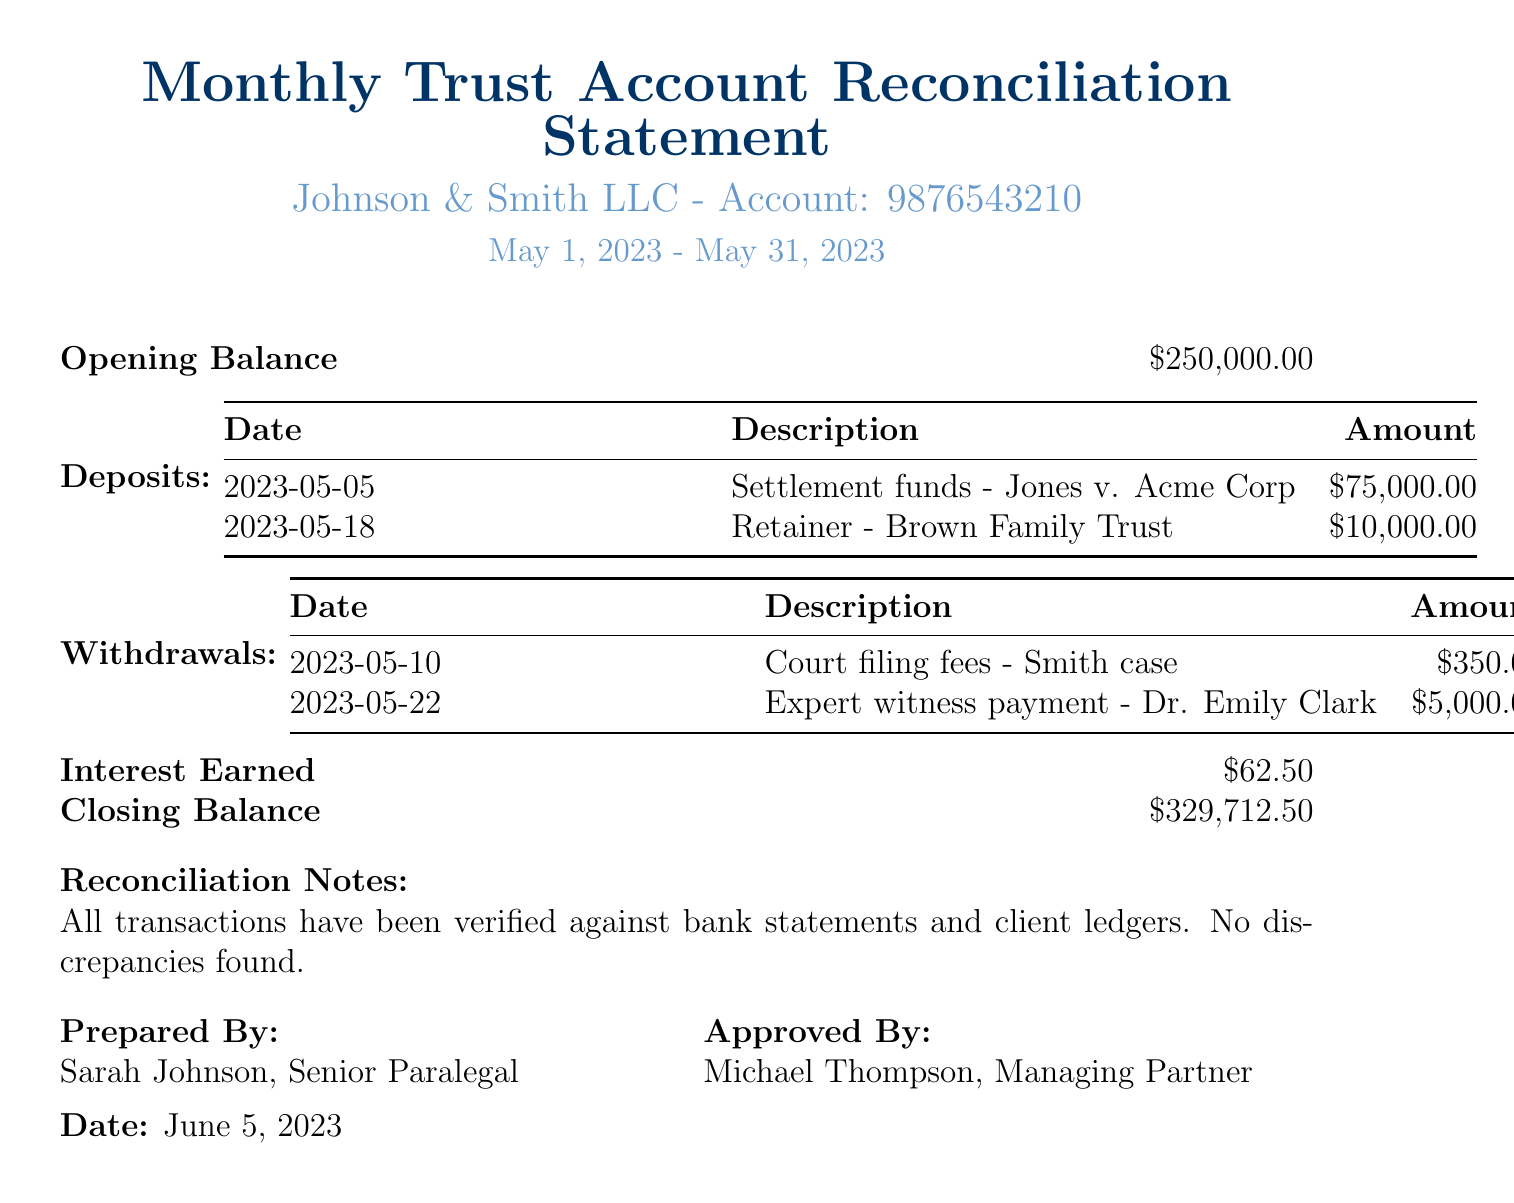What is the client name? The client name is clearly stated in the document as Johnson & Smith LLC.
Answer: Johnson & Smith LLC What is the account number? The account number is directly referenced in the document, listed as 9876543210.
Answer: 9876543210 What is the opening balance? The document specifies the opening balance at the start of the reporting period as $250,000.00.
Answer: $250,000.00 How much was withdrawn on May 10? The document lists the withdrawal date and amounts, specifically indicating a withdrawal of $350.00 on May 10.
Answer: $350.00 What is the total amount of deposits? The total deposits can be calculated by adding the two deposits of $75,000.00 and $10,000.00, which results in $85,000.00.
Answer: $85,000.00 What is the interest earned during the reporting period? The document specifies that the interest earned is $62.50.
Answer: $62.50 What is the closing balance? The closing balance is clearly stated at the end of the document as $329,712.50.
Answer: $329,712.50 What was the purpose of the withdrawal on May 22? The document states the purpose of the withdrawal on May 22 was for an expert witness payment to Dr. Emily Clark.
Answer: Expert witness payment - Dr. Emily Clark What were the reconciliation notes? The document summarizes the reconciliation notes indicating that all transactions have been verified against bank statements and client ledgers with no discrepancies found.
Answer: All transactions have been verified against bank statements and client ledgers. No discrepancies found 